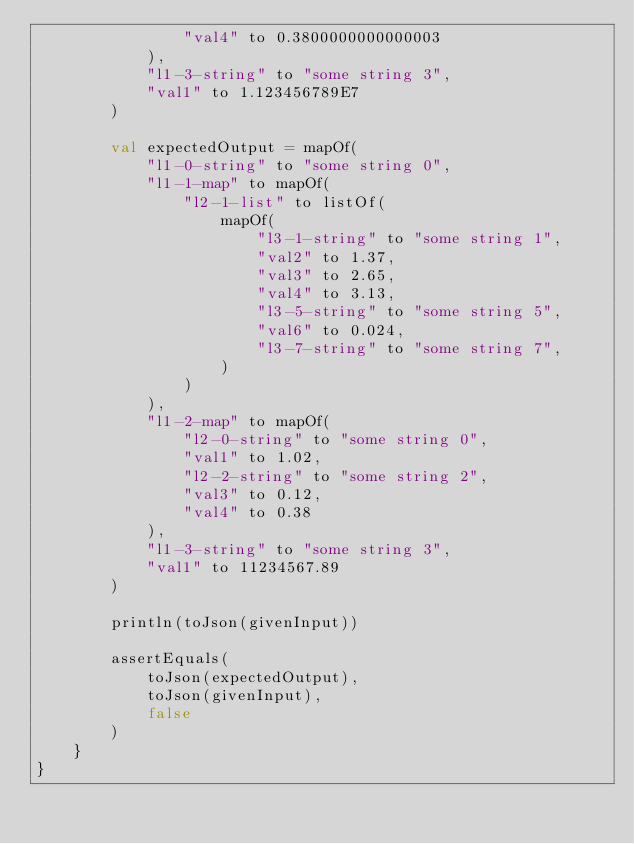Convert code to text. <code><loc_0><loc_0><loc_500><loc_500><_Kotlin_>                "val4" to 0.3800000000000003
            ),
            "l1-3-string" to "some string 3",
            "val1" to 1.123456789E7
        )

        val expectedOutput = mapOf(
            "l1-0-string" to "some string 0",
            "l1-1-map" to mapOf(
                "l2-1-list" to listOf(
                    mapOf(
                        "l3-1-string" to "some string 1",
                        "val2" to 1.37,
                        "val3" to 2.65,
                        "val4" to 3.13,
                        "l3-5-string" to "some string 5",
                        "val6" to 0.024,
                        "l3-7-string" to "some string 7",
                    )
                )
            ),
            "l1-2-map" to mapOf(
                "l2-0-string" to "some string 0",
                "val1" to 1.02,
                "l2-2-string" to "some string 2",
                "val3" to 0.12,
                "val4" to 0.38
            ),
            "l1-3-string" to "some string 3",
            "val1" to 11234567.89
        )

        println(toJson(givenInput))

        assertEquals(
            toJson(expectedOutput),
            toJson(givenInput),
            false
        )
    }
}</code> 